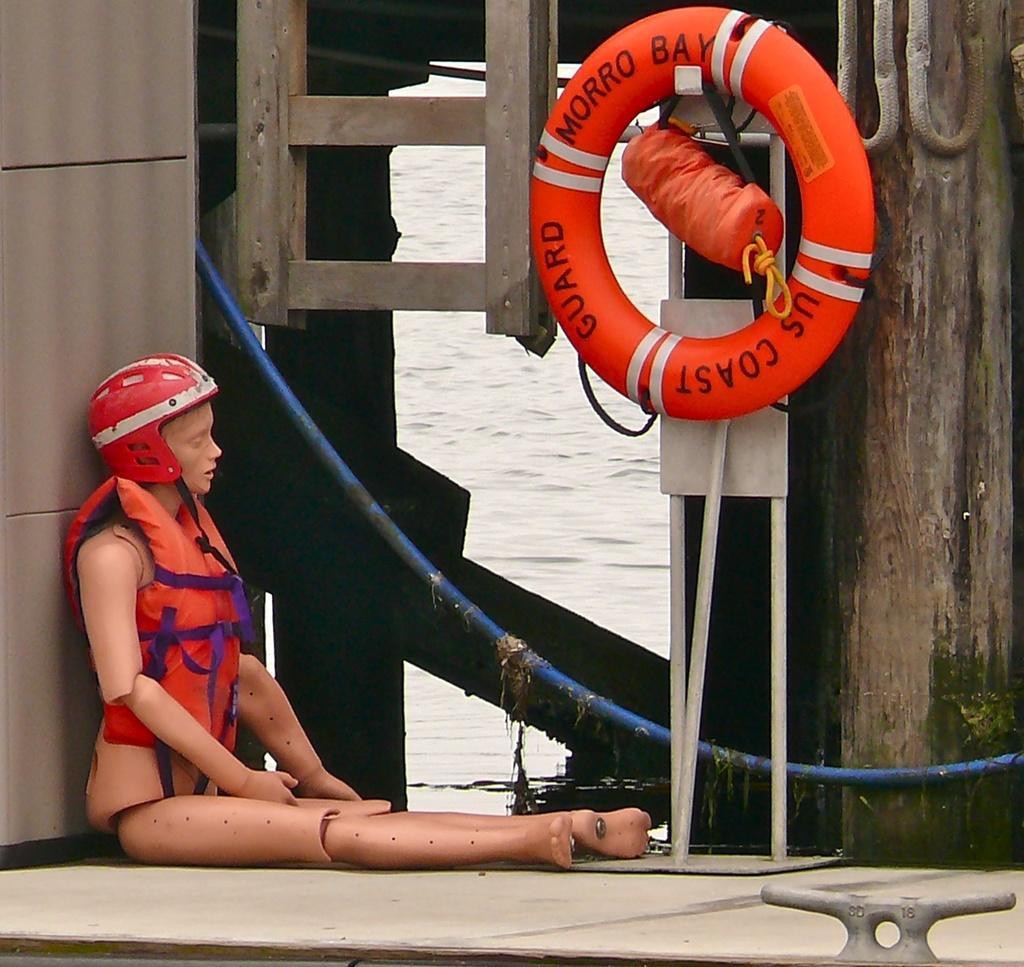Could you give a brief overview of what you see in this image? In this picture there is a statue of a woman who is wearing helmet and jacket. In the top right I can see the tube which is hanging on the wood. In the back I can see the water flow. On the left I can see the wooden partition. 